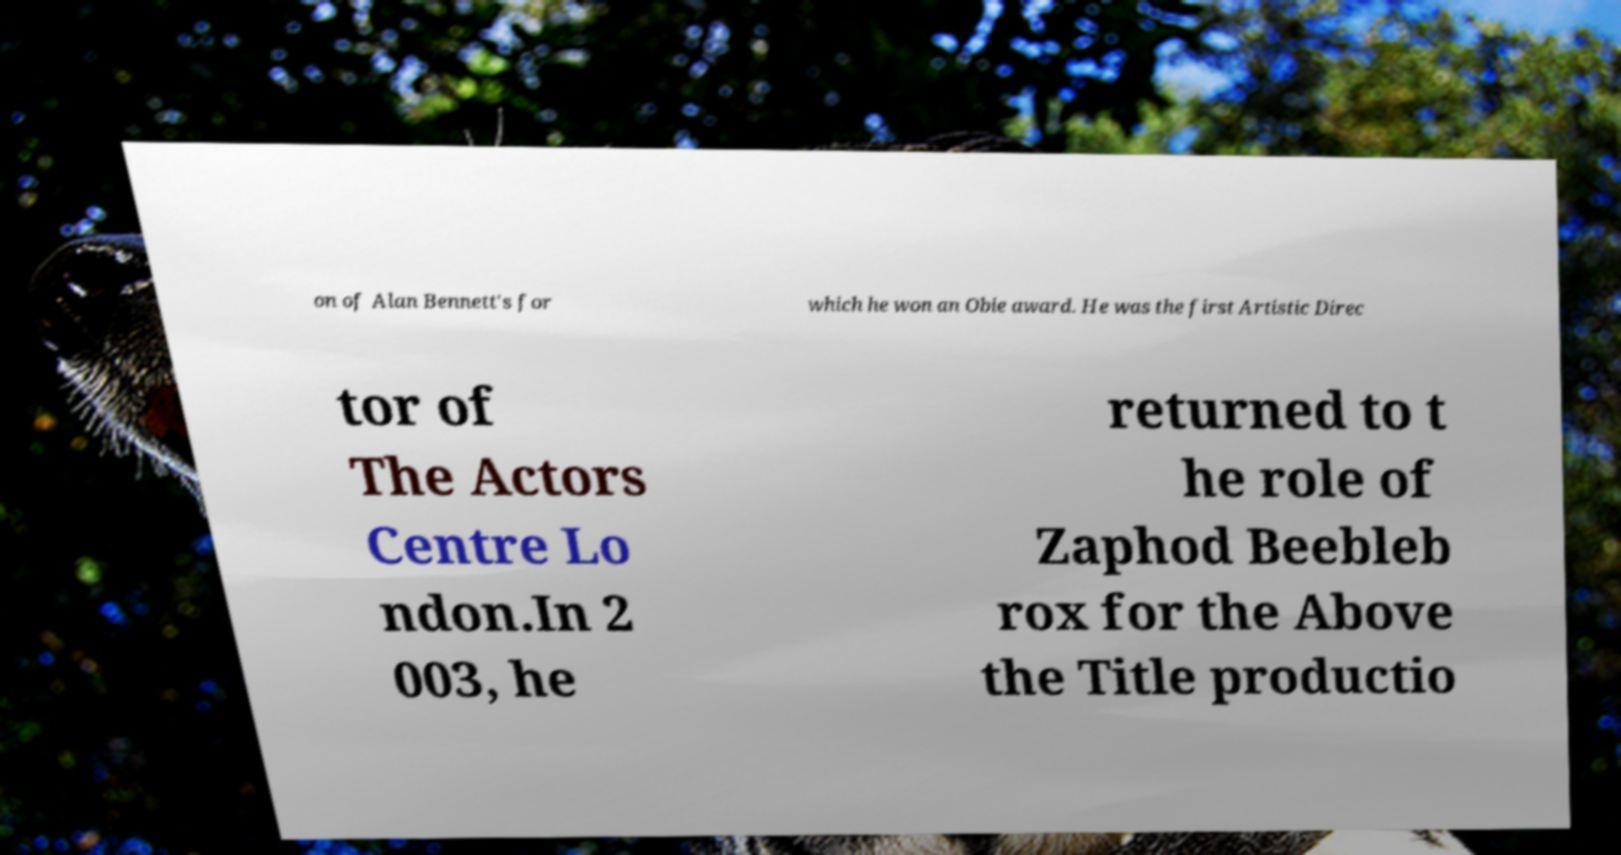For documentation purposes, I need the text within this image transcribed. Could you provide that? on of Alan Bennett's for which he won an Obie award. He was the first Artistic Direc tor of The Actors Centre Lo ndon.In 2 003, he returned to t he role of Zaphod Beebleb rox for the Above the Title productio 